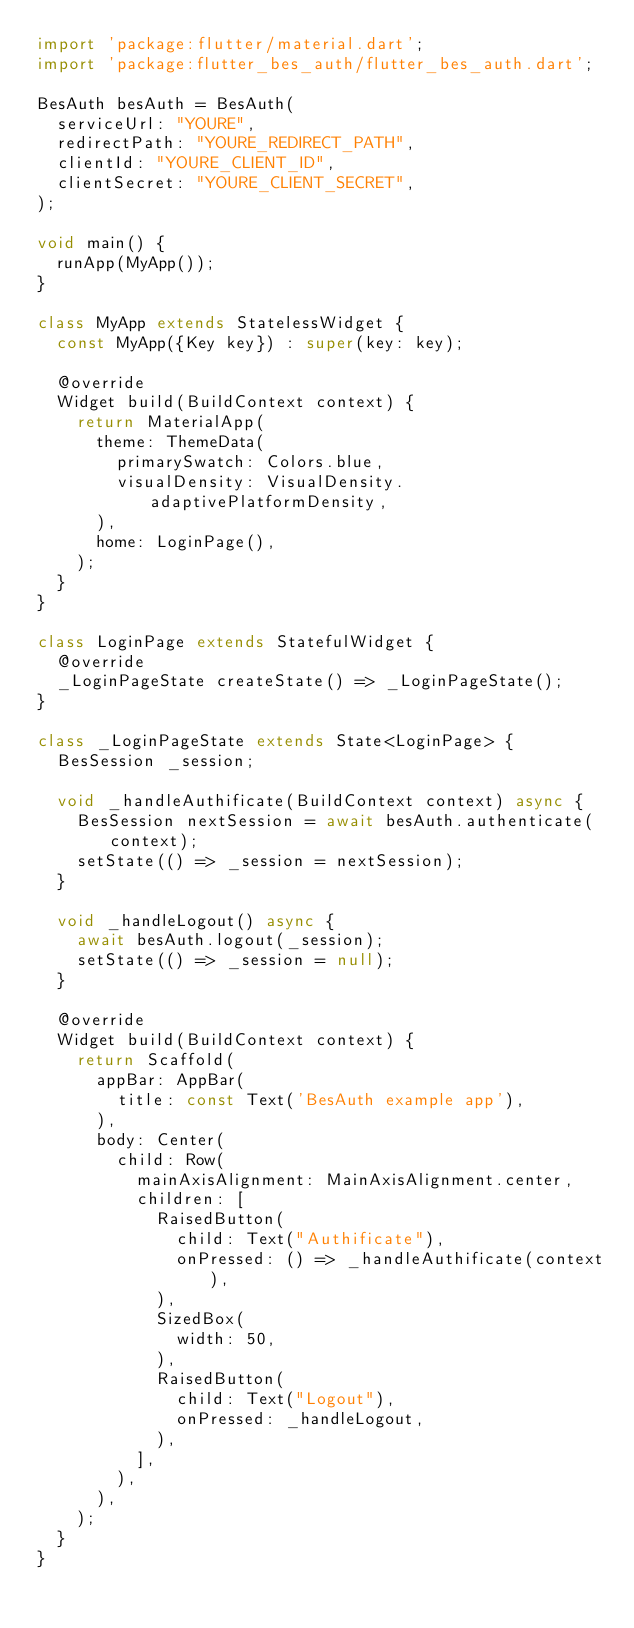Convert code to text. <code><loc_0><loc_0><loc_500><loc_500><_Dart_>import 'package:flutter/material.dart';
import 'package:flutter_bes_auth/flutter_bes_auth.dart';

BesAuth besAuth = BesAuth(
  serviceUrl: "YOURE",
  redirectPath: "YOURE_REDIRECT_PATH",
  clientId: "YOURE_CLIENT_ID",
  clientSecret: "YOURE_CLIENT_SECRET",
);

void main() {
  runApp(MyApp());
}

class MyApp extends StatelessWidget {
  const MyApp({Key key}) : super(key: key);

  @override
  Widget build(BuildContext context) {
    return MaterialApp(
      theme: ThemeData(
        primarySwatch: Colors.blue,
        visualDensity: VisualDensity.adaptivePlatformDensity,
      ),
      home: LoginPage(),
    );
  }
}

class LoginPage extends StatefulWidget {
  @override
  _LoginPageState createState() => _LoginPageState();
}

class _LoginPageState extends State<LoginPage> {
  BesSession _session;

  void _handleAuthificate(BuildContext context) async {
    BesSession nextSession = await besAuth.authenticate(context);
    setState(() => _session = nextSession);
  }

  void _handleLogout() async {
    await besAuth.logout(_session);
    setState(() => _session = null);
  }

  @override
  Widget build(BuildContext context) {
    return Scaffold(
      appBar: AppBar(
        title: const Text('BesAuth example app'),
      ),
      body: Center(
        child: Row(
          mainAxisAlignment: MainAxisAlignment.center,
          children: [
            RaisedButton(
              child: Text("Authificate"),
              onPressed: () => _handleAuthificate(context),
            ),
            SizedBox(
              width: 50,
            ),
            RaisedButton(
              child: Text("Logout"),
              onPressed: _handleLogout,
            ),
          ],
        ),
      ),
    );
  }
}
</code> 